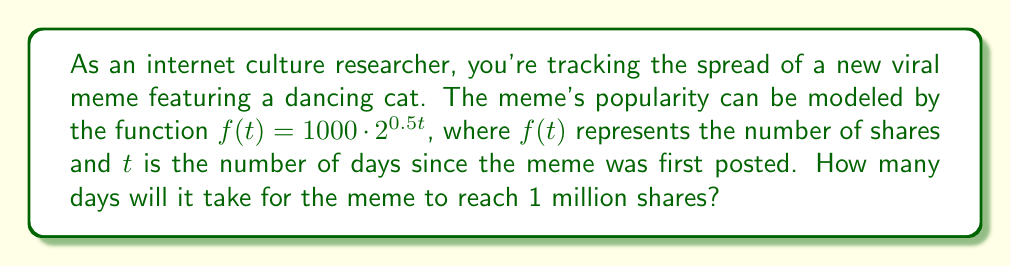Show me your answer to this math problem. To solve this problem, we need to use the exponential function given and set it equal to 1 million shares. Then we'll solve for $t$.

1) We start with the equation:
   $f(t) = 1000 \cdot 2^{0.5t}$

2) We want to find when $f(t) = 1,000,000$, so we set up the equation:
   $1,000,000 = 1000 \cdot 2^{0.5t}$

3) Divide both sides by 1000:
   $1,000 = 2^{0.5t}$

4) Take the logarithm (base 2) of both sides:
   $\log_2(1000) = \log_2(2^{0.5t})$

5) Using the logarithm property $\log_a(a^x) = x$, we get:
   $\log_2(1000) = 0.5t$

6) Solve for $t$:
   $t = \frac{\log_2(1000)}{0.5}$

7) Calculate:
   $\log_2(1000) \approx 9.97$
   $t = \frac{9.97}{0.5} \approx 19.93$

8) Since we can't have a fractional day, we round up to the next whole day.

Therefore, it will take 20 days for the meme to reach 1 million shares.
Answer: 20 days 